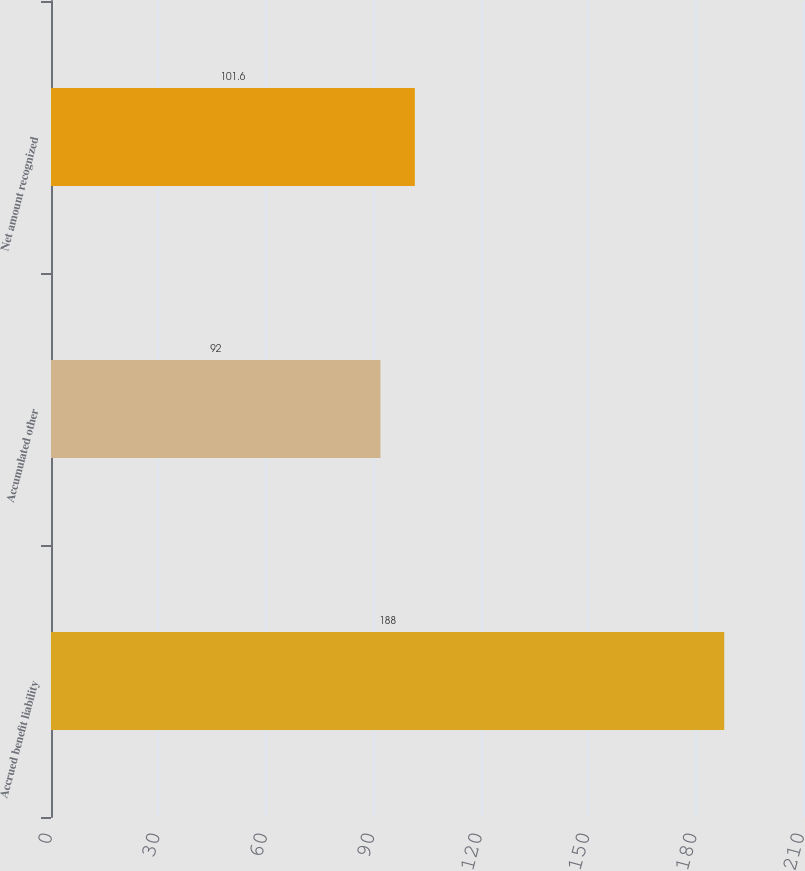<chart> <loc_0><loc_0><loc_500><loc_500><bar_chart><fcel>Accrued benefit liability<fcel>Accumulated other<fcel>Net amount recognized<nl><fcel>188<fcel>92<fcel>101.6<nl></chart> 